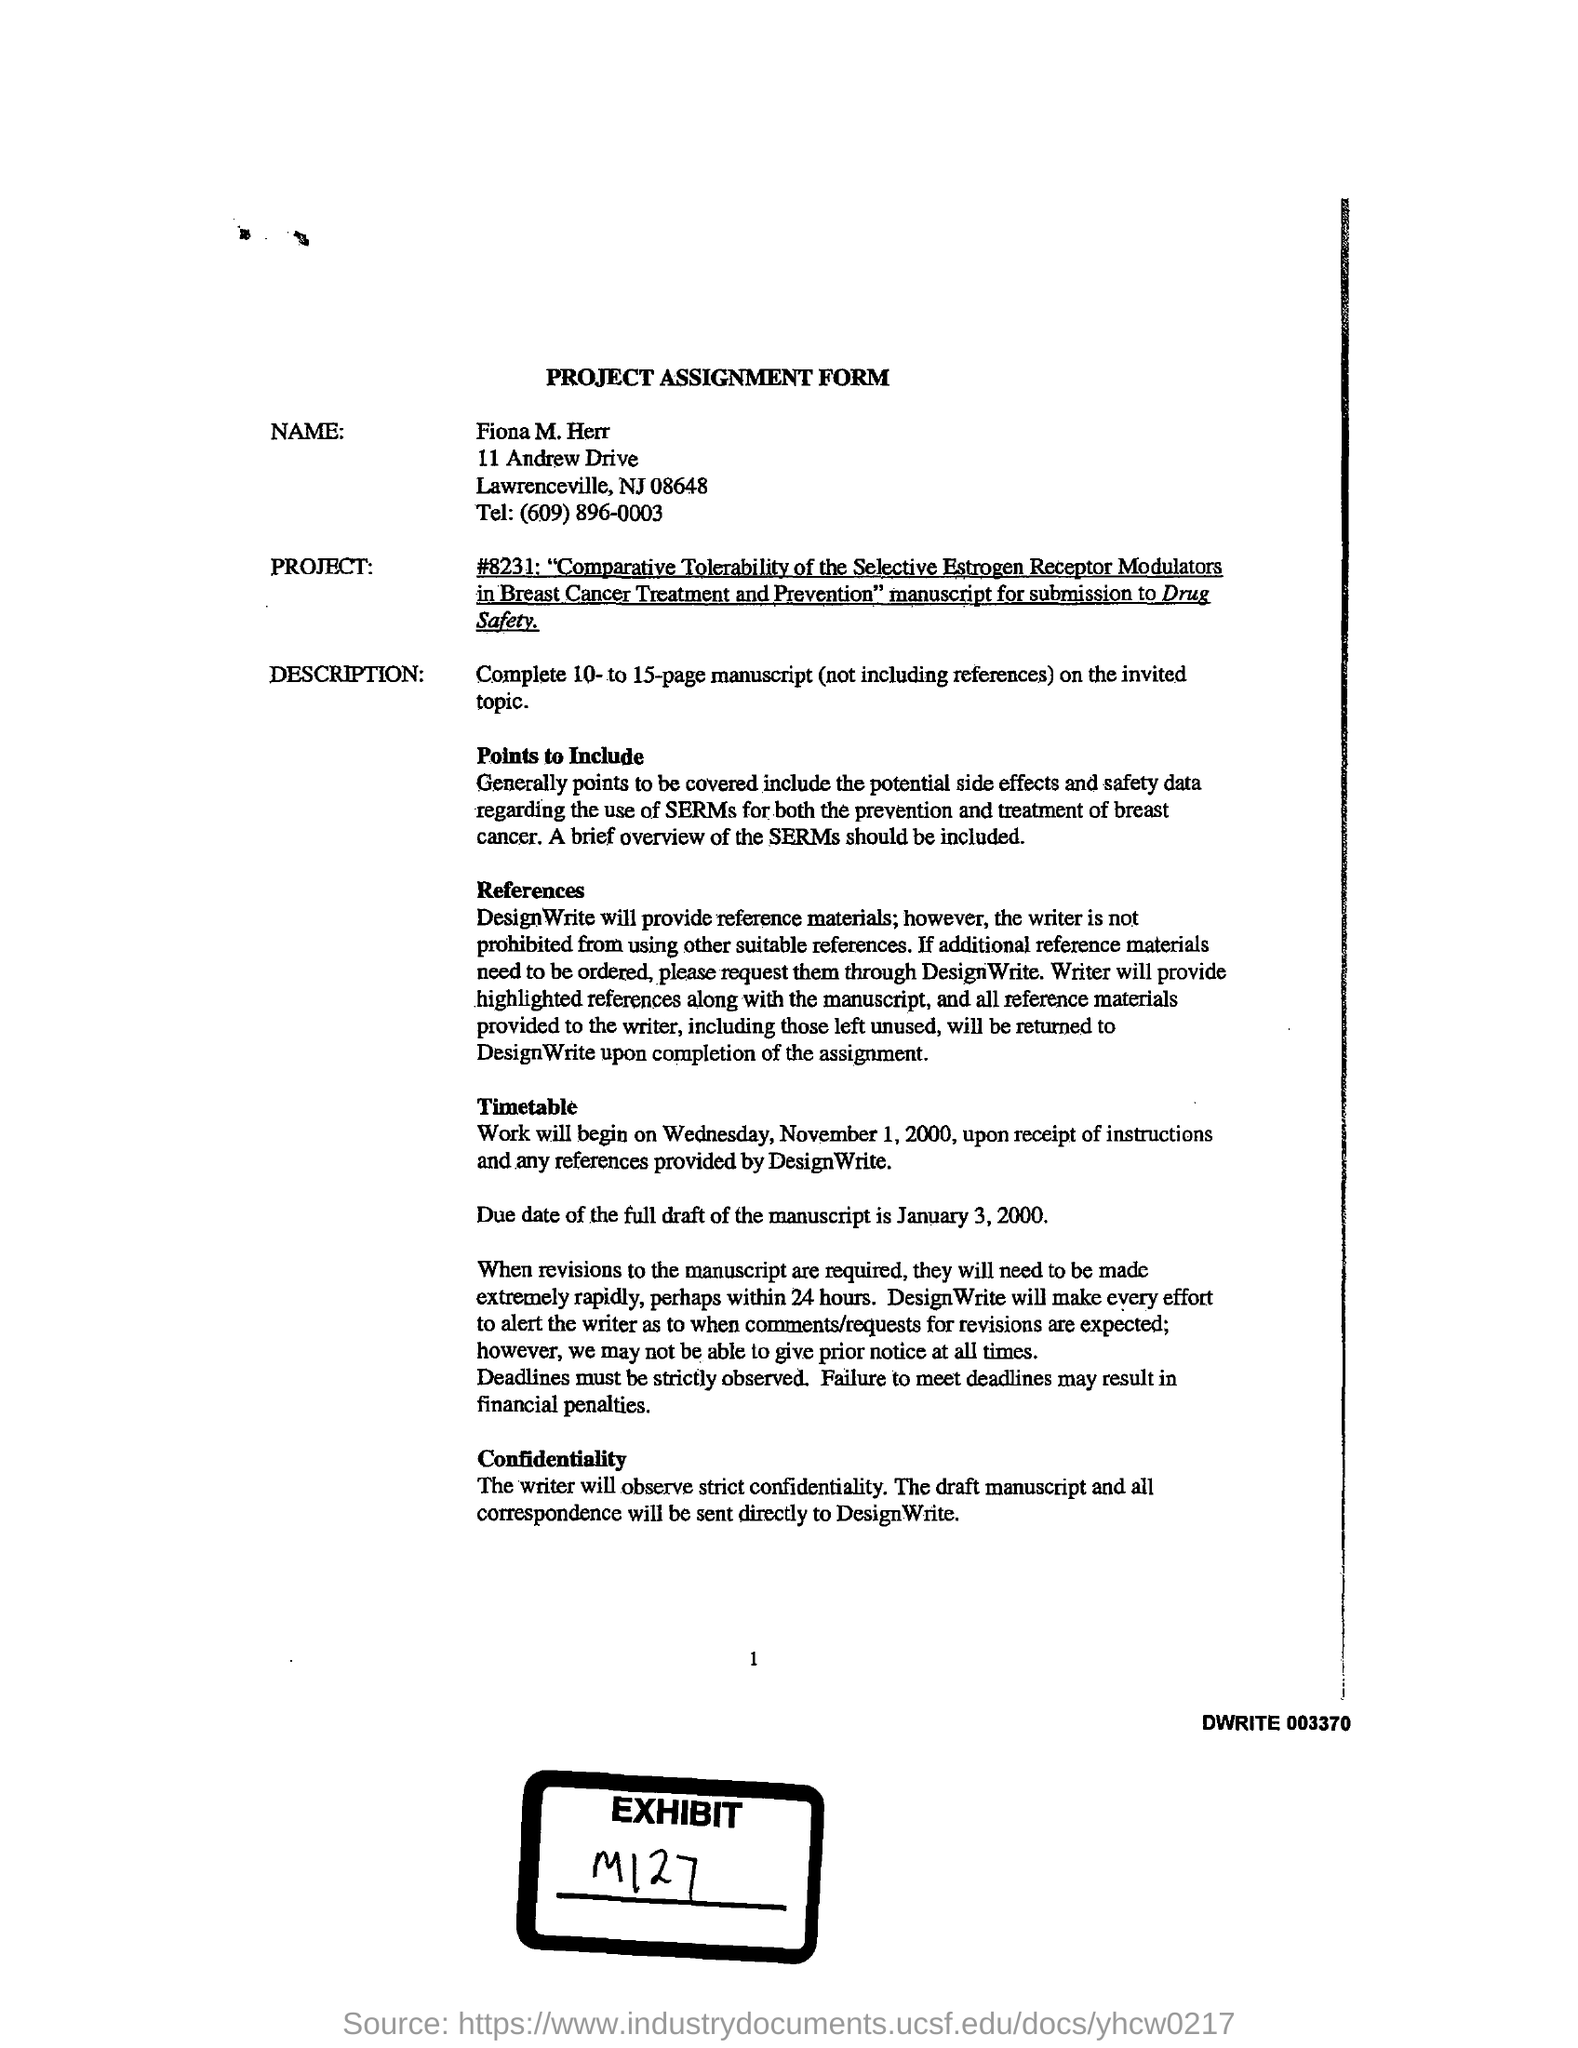WHO'S NAME WAS WRITTEN IN THE PROJECT ASSIGNMENT FORM ?
Make the answer very short. Fiona M.Herr. What is the tel number given in the assignment form ?
Provide a short and direct response. (609) 896-0003. What is the due date of the full draft of the manuscript ?
Your answer should be very brief. January 3, 2000. 